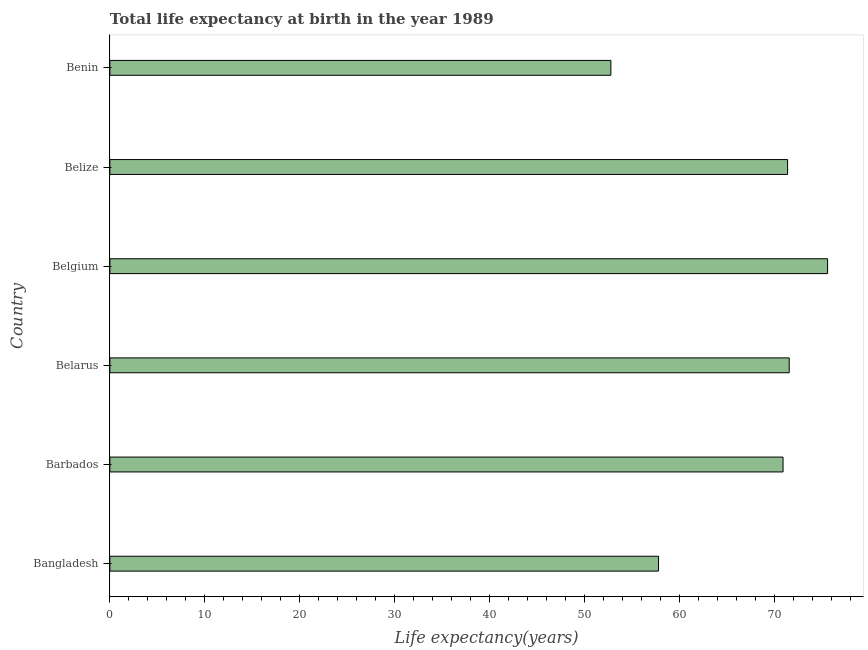Does the graph contain any zero values?
Keep it short and to the point. No. What is the title of the graph?
Make the answer very short. Total life expectancy at birth in the year 1989. What is the label or title of the X-axis?
Keep it short and to the point. Life expectancy(years). What is the label or title of the Y-axis?
Give a very brief answer. Country. What is the life expectancy at birth in Bangladesh?
Make the answer very short. 57.82. Across all countries, what is the maximum life expectancy at birth?
Give a very brief answer. 75.63. Across all countries, what is the minimum life expectancy at birth?
Provide a short and direct response. 52.79. In which country was the life expectancy at birth maximum?
Ensure brevity in your answer.  Belgium. In which country was the life expectancy at birth minimum?
Ensure brevity in your answer.  Benin. What is the sum of the life expectancy at birth?
Give a very brief answer. 400.18. What is the difference between the life expectancy at birth in Bangladesh and Benin?
Offer a very short reply. 5.02. What is the average life expectancy at birth per country?
Keep it short and to the point. 66.7. What is the median life expectancy at birth?
Offer a terse response. 71.18. In how many countries, is the life expectancy at birth greater than 56 years?
Provide a short and direct response. 5. What is the ratio of the life expectancy at birth in Bangladesh to that in Belize?
Keep it short and to the point. 0.81. Is the life expectancy at birth in Belize less than that in Benin?
Offer a very short reply. No. What is the difference between the highest and the second highest life expectancy at birth?
Give a very brief answer. 4.04. Is the sum of the life expectancy at birth in Belgium and Belize greater than the maximum life expectancy at birth across all countries?
Make the answer very short. Yes. What is the difference between the highest and the lowest life expectancy at birth?
Your answer should be very brief. 22.84. In how many countries, is the life expectancy at birth greater than the average life expectancy at birth taken over all countries?
Keep it short and to the point. 4. How many bars are there?
Your answer should be compact. 6. Are all the bars in the graph horizontal?
Keep it short and to the point. Yes. What is the difference between two consecutive major ticks on the X-axis?
Give a very brief answer. 10. What is the Life expectancy(years) in Bangladesh?
Offer a terse response. 57.82. What is the Life expectancy(years) of Barbados?
Provide a succinct answer. 70.94. What is the Life expectancy(years) of Belarus?
Your response must be concise. 71.59. What is the Life expectancy(years) in Belgium?
Provide a succinct answer. 75.63. What is the Life expectancy(years) of Belize?
Your answer should be compact. 71.42. What is the Life expectancy(years) in Benin?
Your answer should be compact. 52.79. What is the difference between the Life expectancy(years) in Bangladesh and Barbados?
Ensure brevity in your answer.  -13.12. What is the difference between the Life expectancy(years) in Bangladesh and Belarus?
Offer a terse response. -13.77. What is the difference between the Life expectancy(years) in Bangladesh and Belgium?
Offer a terse response. -17.82. What is the difference between the Life expectancy(years) in Bangladesh and Belize?
Keep it short and to the point. -13.6. What is the difference between the Life expectancy(years) in Bangladesh and Benin?
Provide a short and direct response. 5.02. What is the difference between the Life expectancy(years) in Barbados and Belarus?
Provide a short and direct response. -0.65. What is the difference between the Life expectancy(years) in Barbados and Belgium?
Provide a succinct answer. -4.7. What is the difference between the Life expectancy(years) in Barbados and Belize?
Make the answer very short. -0.48. What is the difference between the Life expectancy(years) in Barbados and Benin?
Ensure brevity in your answer.  18.14. What is the difference between the Life expectancy(years) in Belarus and Belgium?
Your answer should be compact. -4.04. What is the difference between the Life expectancy(years) in Belarus and Belize?
Ensure brevity in your answer.  0.17. What is the difference between the Life expectancy(years) in Belarus and Benin?
Give a very brief answer. 18.79. What is the difference between the Life expectancy(years) in Belgium and Belize?
Ensure brevity in your answer.  4.21. What is the difference between the Life expectancy(years) in Belgium and Benin?
Offer a terse response. 22.84. What is the difference between the Life expectancy(years) in Belize and Benin?
Provide a short and direct response. 18.63. What is the ratio of the Life expectancy(years) in Bangladesh to that in Barbados?
Your answer should be compact. 0.81. What is the ratio of the Life expectancy(years) in Bangladesh to that in Belarus?
Provide a succinct answer. 0.81. What is the ratio of the Life expectancy(years) in Bangladesh to that in Belgium?
Your answer should be very brief. 0.76. What is the ratio of the Life expectancy(years) in Bangladesh to that in Belize?
Your answer should be compact. 0.81. What is the ratio of the Life expectancy(years) in Bangladesh to that in Benin?
Keep it short and to the point. 1.09. What is the ratio of the Life expectancy(years) in Barbados to that in Belarus?
Keep it short and to the point. 0.99. What is the ratio of the Life expectancy(years) in Barbados to that in Belgium?
Offer a very short reply. 0.94. What is the ratio of the Life expectancy(years) in Barbados to that in Belize?
Your answer should be very brief. 0.99. What is the ratio of the Life expectancy(years) in Barbados to that in Benin?
Offer a terse response. 1.34. What is the ratio of the Life expectancy(years) in Belarus to that in Belgium?
Offer a very short reply. 0.95. What is the ratio of the Life expectancy(years) in Belarus to that in Belize?
Keep it short and to the point. 1. What is the ratio of the Life expectancy(years) in Belarus to that in Benin?
Your response must be concise. 1.36. What is the ratio of the Life expectancy(years) in Belgium to that in Belize?
Keep it short and to the point. 1.06. What is the ratio of the Life expectancy(years) in Belgium to that in Benin?
Keep it short and to the point. 1.43. What is the ratio of the Life expectancy(years) in Belize to that in Benin?
Your answer should be very brief. 1.35. 